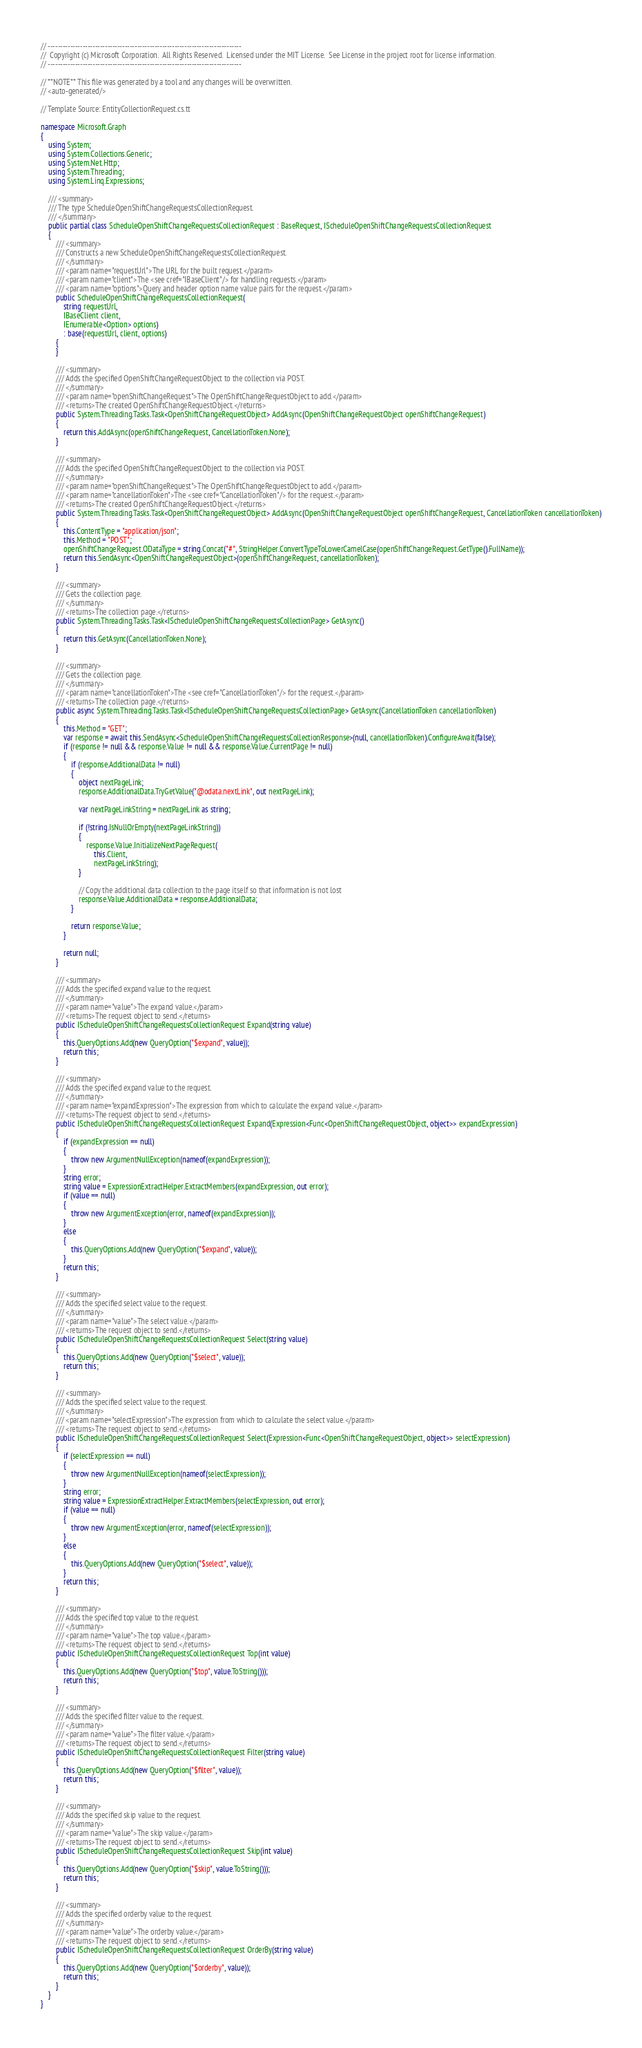Convert code to text. <code><loc_0><loc_0><loc_500><loc_500><_C#_>// ------------------------------------------------------------------------------
//  Copyright (c) Microsoft Corporation.  All Rights Reserved.  Licensed under the MIT License.  See License in the project root for license information.
// ------------------------------------------------------------------------------

// **NOTE** This file was generated by a tool and any changes will be overwritten.
// <auto-generated/>

// Template Source: EntityCollectionRequest.cs.tt

namespace Microsoft.Graph
{
    using System;
    using System.Collections.Generic;
    using System.Net.Http;
    using System.Threading;
    using System.Linq.Expressions;

    /// <summary>
    /// The type ScheduleOpenShiftChangeRequestsCollectionRequest.
    /// </summary>
    public partial class ScheduleOpenShiftChangeRequestsCollectionRequest : BaseRequest, IScheduleOpenShiftChangeRequestsCollectionRequest
    {
        /// <summary>
        /// Constructs a new ScheduleOpenShiftChangeRequestsCollectionRequest.
        /// </summary>
        /// <param name="requestUrl">The URL for the built request.</param>
        /// <param name="client">The <see cref="IBaseClient"/> for handling requests.</param>
        /// <param name="options">Query and header option name value pairs for the request.</param>
        public ScheduleOpenShiftChangeRequestsCollectionRequest(
            string requestUrl,
            IBaseClient client,
            IEnumerable<Option> options)
            : base(requestUrl, client, options)
        {
        }
        
        /// <summary>
        /// Adds the specified OpenShiftChangeRequestObject to the collection via POST.
        /// </summary>
        /// <param name="openShiftChangeRequest">The OpenShiftChangeRequestObject to add.</param>
        /// <returns>The created OpenShiftChangeRequestObject.</returns>
        public System.Threading.Tasks.Task<OpenShiftChangeRequestObject> AddAsync(OpenShiftChangeRequestObject openShiftChangeRequest)
        {
            return this.AddAsync(openShiftChangeRequest, CancellationToken.None);
        }

        /// <summary>
        /// Adds the specified OpenShiftChangeRequestObject to the collection via POST.
        /// </summary>
        /// <param name="openShiftChangeRequest">The OpenShiftChangeRequestObject to add.</param>
        /// <param name="cancellationToken">The <see cref="CancellationToken"/> for the request.</param>
        /// <returns>The created OpenShiftChangeRequestObject.</returns>
        public System.Threading.Tasks.Task<OpenShiftChangeRequestObject> AddAsync(OpenShiftChangeRequestObject openShiftChangeRequest, CancellationToken cancellationToken)
        {
            this.ContentType = "application/json";
            this.Method = "POST";
            openShiftChangeRequest.ODataType = string.Concat("#", StringHelper.ConvertTypeToLowerCamelCase(openShiftChangeRequest.GetType().FullName));
            return this.SendAsync<OpenShiftChangeRequestObject>(openShiftChangeRequest, cancellationToken);
        }

        /// <summary>
        /// Gets the collection page.
        /// </summary>
        /// <returns>The collection page.</returns>
        public System.Threading.Tasks.Task<IScheduleOpenShiftChangeRequestsCollectionPage> GetAsync()
        {
            return this.GetAsync(CancellationToken.None);
        }

        /// <summary>
        /// Gets the collection page.
        /// </summary>
        /// <param name="cancellationToken">The <see cref="CancellationToken"/> for the request.</param>
        /// <returns>The collection page.</returns>
        public async System.Threading.Tasks.Task<IScheduleOpenShiftChangeRequestsCollectionPage> GetAsync(CancellationToken cancellationToken)
        {
            this.Method = "GET";
            var response = await this.SendAsync<ScheduleOpenShiftChangeRequestsCollectionResponse>(null, cancellationToken).ConfigureAwait(false);
            if (response != null && response.Value != null && response.Value.CurrentPage != null)
            {
                if (response.AdditionalData != null)
                {
                    object nextPageLink;
                    response.AdditionalData.TryGetValue("@odata.nextLink", out nextPageLink);

                    var nextPageLinkString = nextPageLink as string;

                    if (!string.IsNullOrEmpty(nextPageLinkString))
                    {
                        response.Value.InitializeNextPageRequest(
                            this.Client,
                            nextPageLinkString);
                    }

                    // Copy the additional data collection to the page itself so that information is not lost
                    response.Value.AdditionalData = response.AdditionalData;
                }

                return response.Value;
            }

            return null;
        }

        /// <summary>
        /// Adds the specified expand value to the request.
        /// </summary>
        /// <param name="value">The expand value.</param>
        /// <returns>The request object to send.</returns>
        public IScheduleOpenShiftChangeRequestsCollectionRequest Expand(string value)
        {
            this.QueryOptions.Add(new QueryOption("$expand", value));
            return this;
        }

        /// <summary>
        /// Adds the specified expand value to the request.
        /// </summary>
        /// <param name="expandExpression">The expression from which to calculate the expand value.</param>
        /// <returns>The request object to send.</returns>
        public IScheduleOpenShiftChangeRequestsCollectionRequest Expand(Expression<Func<OpenShiftChangeRequestObject, object>> expandExpression)
        {
            if (expandExpression == null)
            {
                throw new ArgumentNullException(nameof(expandExpression));
            }
            string error;
            string value = ExpressionExtractHelper.ExtractMembers(expandExpression, out error);
            if (value == null)
            {
                throw new ArgumentException(error, nameof(expandExpression));
            }
            else
            {
                this.QueryOptions.Add(new QueryOption("$expand", value));
            }
            return this;
        }

        /// <summary>
        /// Adds the specified select value to the request.
        /// </summary>
        /// <param name="value">The select value.</param>
        /// <returns>The request object to send.</returns>
        public IScheduleOpenShiftChangeRequestsCollectionRequest Select(string value)
        {
            this.QueryOptions.Add(new QueryOption("$select", value));
            return this;
        }

        /// <summary>
        /// Adds the specified select value to the request.
        /// </summary>
        /// <param name="selectExpression">The expression from which to calculate the select value.</param>
        /// <returns>The request object to send.</returns>
        public IScheduleOpenShiftChangeRequestsCollectionRequest Select(Expression<Func<OpenShiftChangeRequestObject, object>> selectExpression)
        {
            if (selectExpression == null)
            {
                throw new ArgumentNullException(nameof(selectExpression));
            }
            string error;
            string value = ExpressionExtractHelper.ExtractMembers(selectExpression, out error);
            if (value == null)
            {
                throw new ArgumentException(error, nameof(selectExpression));
            }
            else
            {
                this.QueryOptions.Add(new QueryOption("$select", value));
            }
            return this;
        }

        /// <summary>
        /// Adds the specified top value to the request.
        /// </summary>
        /// <param name="value">The top value.</param>
        /// <returns>The request object to send.</returns>
        public IScheduleOpenShiftChangeRequestsCollectionRequest Top(int value)
        {
            this.QueryOptions.Add(new QueryOption("$top", value.ToString()));
            return this;
        }

        /// <summary>
        /// Adds the specified filter value to the request.
        /// </summary>
        /// <param name="value">The filter value.</param>
        /// <returns>The request object to send.</returns>
        public IScheduleOpenShiftChangeRequestsCollectionRequest Filter(string value)
        {
            this.QueryOptions.Add(new QueryOption("$filter", value));
            return this;
        }

        /// <summary>
        /// Adds the specified skip value to the request.
        /// </summary>
        /// <param name="value">The skip value.</param>
        /// <returns>The request object to send.</returns>
        public IScheduleOpenShiftChangeRequestsCollectionRequest Skip(int value)
        {
            this.QueryOptions.Add(new QueryOption("$skip", value.ToString()));
            return this;
        }

        /// <summary>
        /// Adds the specified orderby value to the request.
        /// </summary>
        /// <param name="value">The orderby value.</param>
        /// <returns>The request object to send.</returns>
        public IScheduleOpenShiftChangeRequestsCollectionRequest OrderBy(string value)
        {
            this.QueryOptions.Add(new QueryOption("$orderby", value));
            return this;
        }
    }
}
</code> 